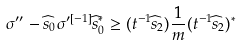Convert formula to latex. <formula><loc_0><loc_0><loc_500><loc_500>\sigma ^ { \prime \prime } - \widehat { s } _ { 0 } \sigma ^ { \prime [ - 1 ] } \widehat { s } _ { 0 } ^ { * } \geq ( t ^ { - 1 } \widehat { s } _ { 2 } ) \frac { 1 } { m } ( t ^ { - 1 } \widehat { s } _ { 2 } ) ^ { * }</formula> 